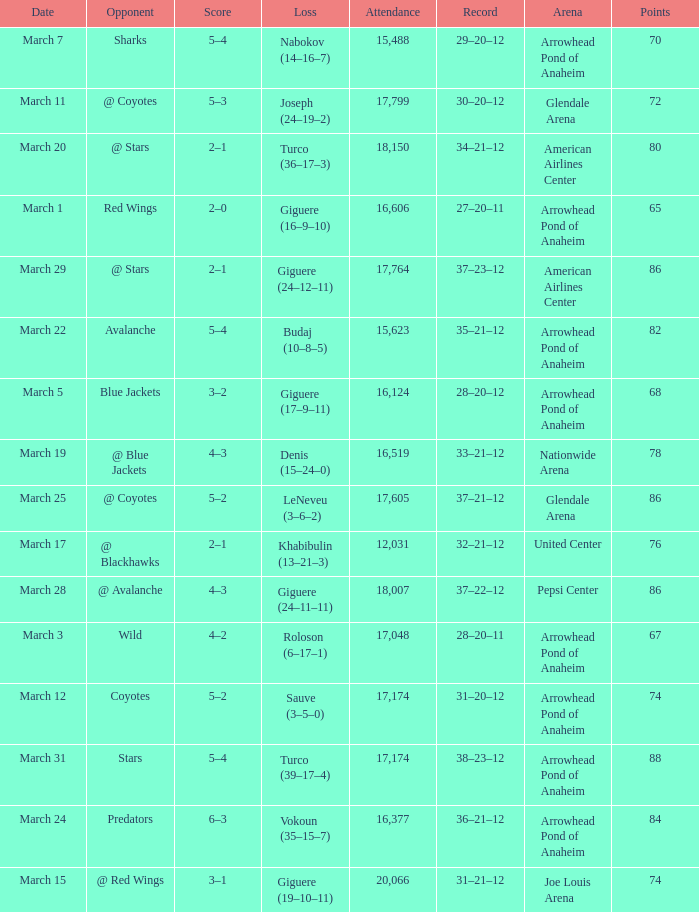Help me parse the entirety of this table. {'header': ['Date', 'Opponent', 'Score', 'Loss', 'Attendance', 'Record', 'Arena', 'Points'], 'rows': [['March 7', 'Sharks', '5–4', 'Nabokov (14–16–7)', '15,488', '29–20–12', 'Arrowhead Pond of Anaheim', '70'], ['March 11', '@ Coyotes', '5–3', 'Joseph (24–19–2)', '17,799', '30–20–12', 'Glendale Arena', '72'], ['March 20', '@ Stars', '2–1', 'Turco (36–17–3)', '18,150', '34–21–12', 'American Airlines Center', '80'], ['March 1', 'Red Wings', '2–0', 'Giguere (16–9–10)', '16,606', '27–20–11', 'Arrowhead Pond of Anaheim', '65'], ['March 29', '@ Stars', '2–1', 'Giguere (24–12–11)', '17,764', '37–23–12', 'American Airlines Center', '86'], ['March 22', 'Avalanche', '5–4', 'Budaj (10–8–5)', '15,623', '35–21–12', 'Arrowhead Pond of Anaheim', '82'], ['March 5', 'Blue Jackets', '3–2', 'Giguere (17–9–11)', '16,124', '28–20–12', 'Arrowhead Pond of Anaheim', '68'], ['March 19', '@ Blue Jackets', '4–3', 'Denis (15–24–0)', '16,519', '33–21–12', 'Nationwide Arena', '78'], ['March 25', '@ Coyotes', '5–2', 'LeNeveu (3–6–2)', '17,605', '37–21–12', 'Glendale Arena', '86'], ['March 17', '@ Blackhawks', '2–1', 'Khabibulin (13–21–3)', '12,031', '32–21–12', 'United Center', '76'], ['March 28', '@ Avalanche', '4–3', 'Giguere (24–11–11)', '18,007', '37–22–12', 'Pepsi Center', '86'], ['March 3', 'Wild', '4–2', 'Roloson (6–17–1)', '17,048', '28–20–11', 'Arrowhead Pond of Anaheim', '67'], ['March 12', 'Coyotes', '5–2', 'Sauve (3–5–0)', '17,174', '31–20–12', 'Arrowhead Pond of Anaheim', '74'], ['March 31', 'Stars', '5–4', 'Turco (39–17–4)', '17,174', '38–23–12', 'Arrowhead Pond of Anaheim', '88'], ['March 24', 'Predators', '6–3', 'Vokoun (35–15–7)', '16,377', '36–21–12', 'Arrowhead Pond of Anaheim', '84'], ['March 15', '@ Red Wings', '3–1', 'Giguere (19–10–11)', '20,066', '31–21–12', 'Joe Louis Arena', '74']]} What is the Attendance at Joe Louis Arena? 20066.0. 